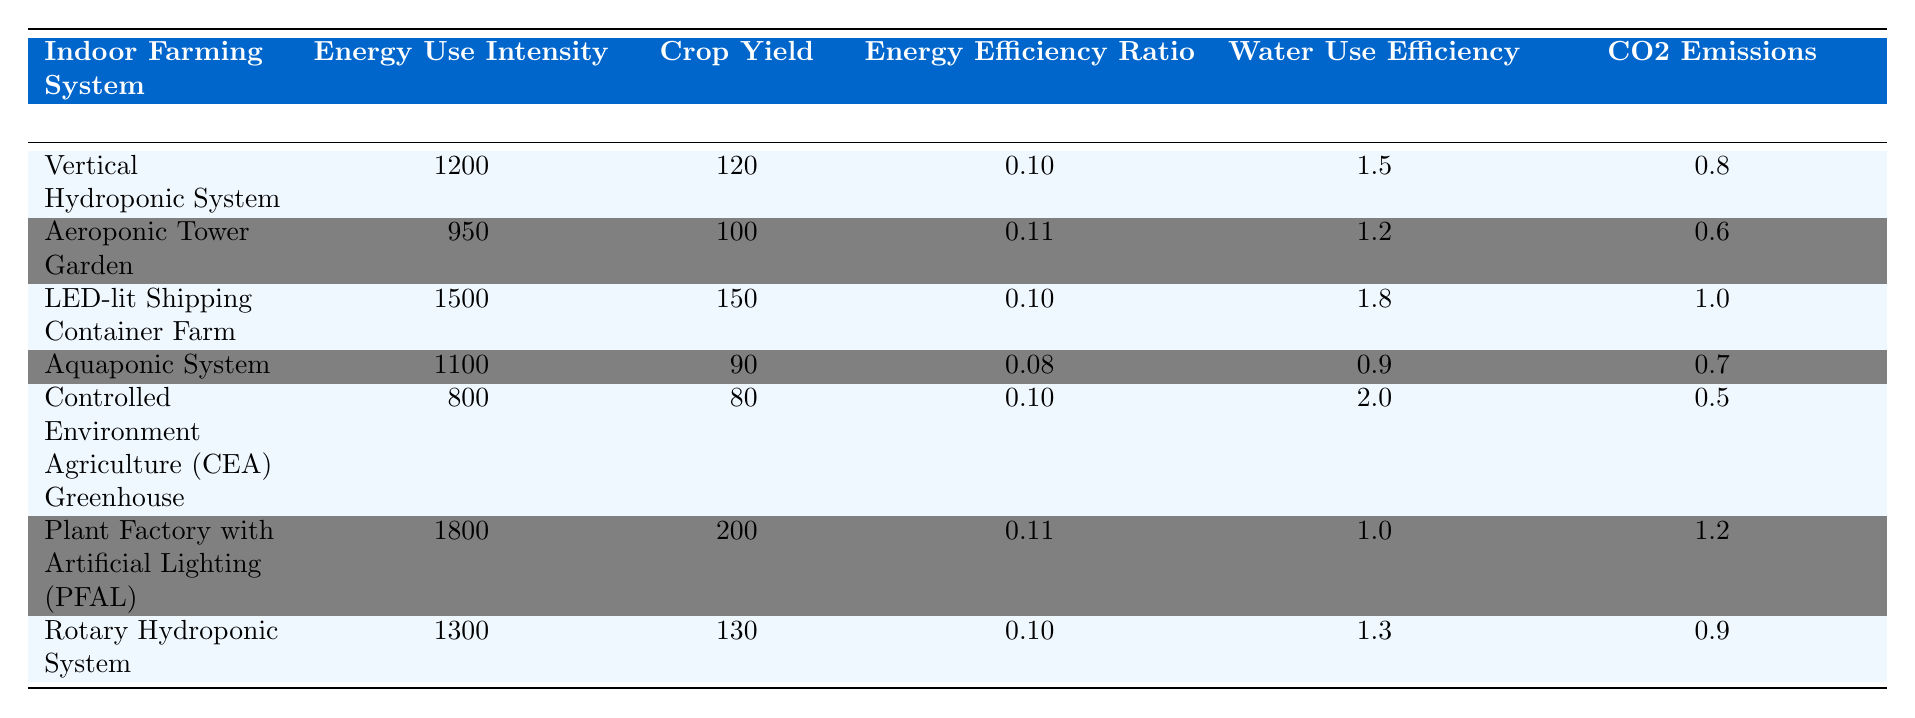What is the Energy Use Intensity of the Controlled Environment Agriculture Greenhouse? The table shows the Energy Use Intensity for each system. For the Controlled Environment Agriculture Greenhouse, it is specified as 800 kWh/m²/year.
Answer: 800 kWh/m²/year Which system has the highest Crop Yield? By checking the Crop Yield values for each system in the table, the Plant Factory with Artificial Lighting has the highest yield at 200 kg/m²/year.
Answer: Plant Factory with Artificial Lighting What is the Energy Efficiency Ratio of the Aquaponic System? The Energy Efficiency Ratio for the Aquaponic System, according to the table, is 0.08 kg/kWh.
Answer: 0.08 kg/kWh Which indoor farming system has the lowest CO2 emissions? The CO2 emissions of each system are listed, with the Controlled Environment Agriculture Greenhouse having the lowest at 0.5 kg CO2e/kg produce.
Answer: Controlled Environment Agriculture Greenhouse What is the average Water Use Efficiency of all systems? First, add the Water Use Efficiency values: 1.5 + 1.2 + 1.8 + 0.9 + 2.0 + 1.0 + 1.3 = 10.7. Then, divide by the number of systems (7): 10.7 / 7 ≈ 1.53 L/kg.
Answer: 1.53 L/kg Is the Energy Efficiency Ratio for the Aeroponic Tower Garden higher than that of the Rotary Hydroponic System? The Energy Efficiency Ratio for the Aeroponic Tower Garden is 0.11 kg/kWh, and for the Rotary Hydroponic System it is 0.10 kg/kWh. This means the Aeroponic Tower Garden's ratio is higher.
Answer: Yes Which system has a lower Crop Yield than the Controlled Environment Agriculture Greenhouse? The Crop Yield for the Controlled Environment Agriculture Greenhouse is 80 kg/m²/year. The systems below this yield are the Aquaponic System (90 kg/m²/year) and the Aeroponic Tower Garden (100 kg/m²/year). Thus, all except the Aquaponic System have higher yields.
Answer: Aquaponic System What is the difference in Energy Use Intensity between the Plant Factory with Artificial Lighting and the Vertical Hydroponic System? The Energy Use Intensity for the Plant Factory is 1800 kWh/m²/year and for the Vertical Hydroponic System it's 1200 kWh/m²/year. The difference is 1800 - 1200 = 600 kWh/m²/year.
Answer: 600 kWh/m²/year Which indoor farming system has both the highest Crop Yield and the highest Energy Efficiency Ratio? The Plant Factory with Artificial Lighting has the highest Crop Yield at 200 kg/m²/year and also has an Energy Efficiency Ratio of 0.11 kg/kWh, which is equal to that of the Aeroponic Tower Garden but has the highest yield.
Answer: Plant Factory with Artificial Lighting 